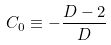Convert formula to latex. <formula><loc_0><loc_0><loc_500><loc_500>C _ { 0 } \equiv - \frac { D - 2 } { D }</formula> 